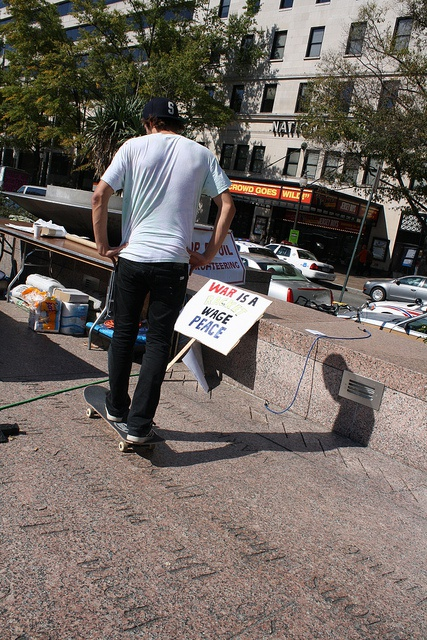Describe the objects in this image and their specific colors. I can see people in darkblue, black, lavender, and gray tones, skateboard in darkblue, black, gray, purple, and darkgray tones, car in navy, gray, black, white, and darkgray tones, car in darkblue, gray, darkgray, black, and lightgray tones, and car in darkblue, white, black, gray, and darkgray tones in this image. 